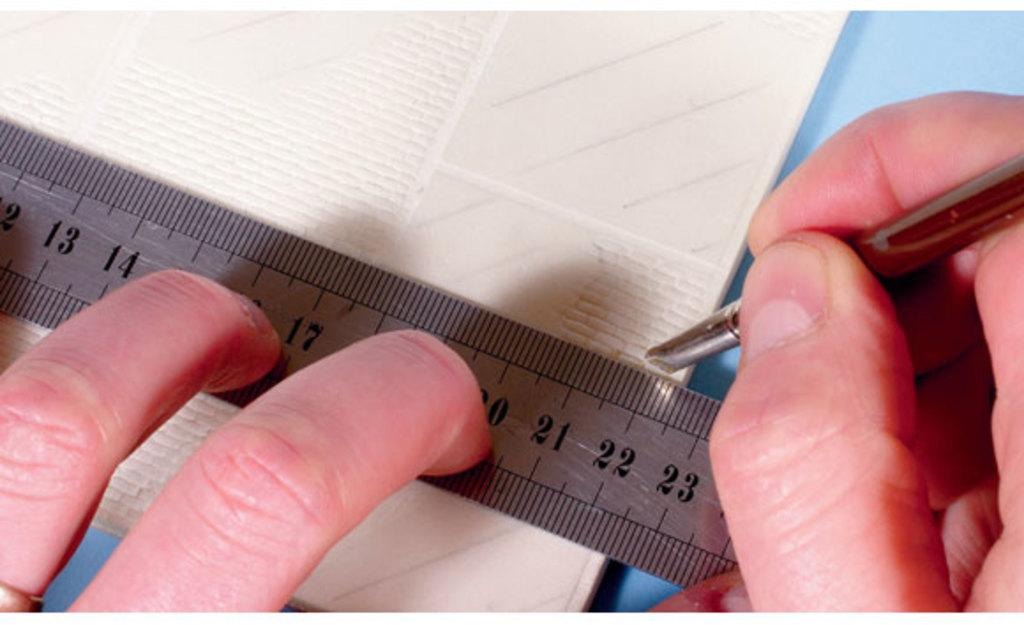<image>
Write a terse but informative summary of the picture. A person drawing or cutting against a ruler at the 22 mark. 